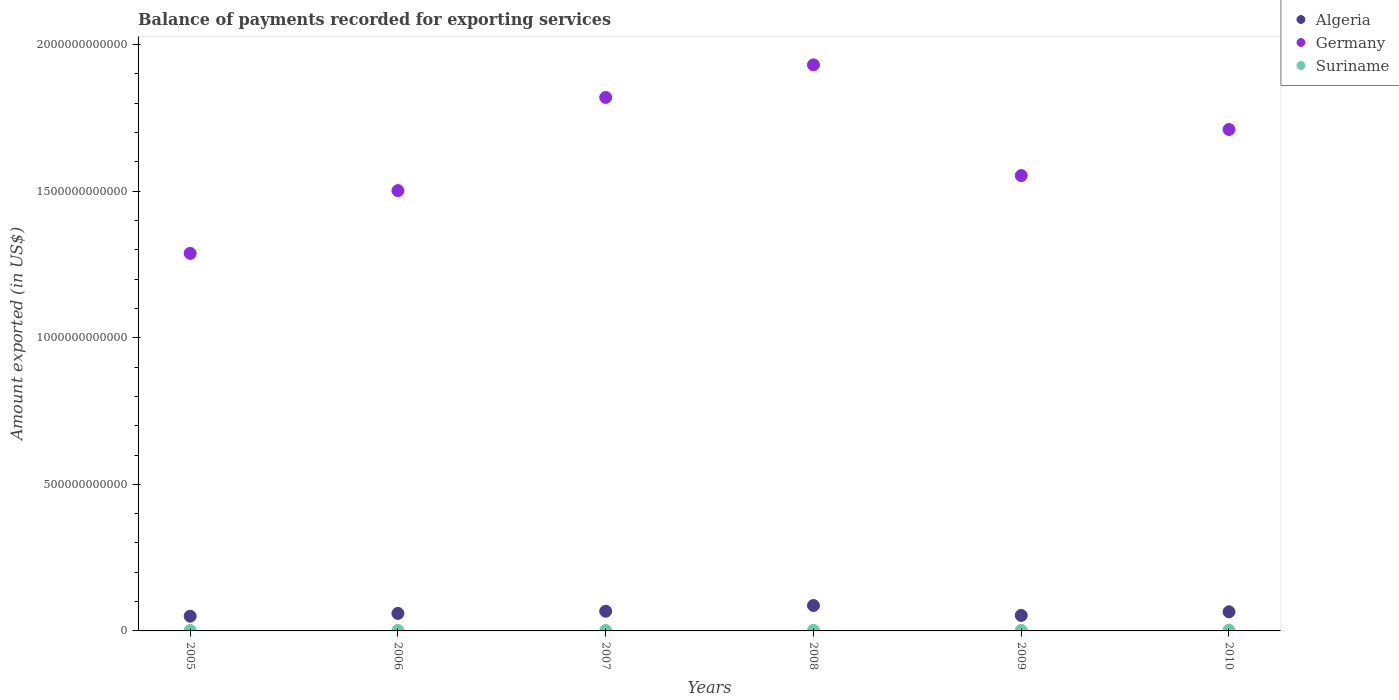How many different coloured dotlines are there?
Your answer should be compact. 3. Is the number of dotlines equal to the number of legend labels?
Provide a succinct answer. Yes. What is the amount exported in Germany in 2006?
Your response must be concise. 1.50e+12. Across all years, what is the maximum amount exported in Suriname?
Provide a short and direct response. 2.35e+09. Across all years, what is the minimum amount exported in Algeria?
Offer a very short reply. 5.03e+1. In which year was the amount exported in Algeria minimum?
Provide a succinct answer. 2005. What is the total amount exported in Germany in the graph?
Provide a short and direct response. 9.80e+12. What is the difference between the amount exported in Germany in 2005 and that in 2010?
Your answer should be very brief. -4.22e+11. What is the difference between the amount exported in Germany in 2006 and the amount exported in Algeria in 2007?
Your response must be concise. 1.43e+12. What is the average amount exported in Germany per year?
Give a very brief answer. 1.63e+12. In the year 2007, what is the difference between the amount exported in Germany and amount exported in Algeria?
Offer a terse response. 1.75e+12. What is the ratio of the amount exported in Algeria in 2006 to that in 2008?
Ensure brevity in your answer.  0.69. Is the amount exported in Germany in 2005 less than that in 2006?
Your response must be concise. Yes. Is the difference between the amount exported in Germany in 2006 and 2010 greater than the difference between the amount exported in Algeria in 2006 and 2010?
Offer a very short reply. No. What is the difference between the highest and the second highest amount exported in Algeria?
Your response must be concise. 1.95e+1. What is the difference between the highest and the lowest amount exported in Germany?
Your answer should be compact. 6.43e+11. Does the amount exported in Algeria monotonically increase over the years?
Make the answer very short. No. How many dotlines are there?
Give a very brief answer. 3. How many years are there in the graph?
Ensure brevity in your answer.  6. What is the difference between two consecutive major ticks on the Y-axis?
Ensure brevity in your answer.  5.00e+11. Are the values on the major ticks of Y-axis written in scientific E-notation?
Give a very brief answer. No. Does the graph contain any zero values?
Your response must be concise. No. Does the graph contain grids?
Give a very brief answer. No. Where does the legend appear in the graph?
Offer a very short reply. Top right. How are the legend labels stacked?
Your answer should be compact. Vertical. What is the title of the graph?
Offer a terse response. Balance of payments recorded for exporting services. What is the label or title of the X-axis?
Provide a short and direct response. Years. What is the label or title of the Y-axis?
Your response must be concise. Amount exported (in US$). What is the Amount exported (in US$) in Algeria in 2005?
Offer a terse response. 5.03e+1. What is the Amount exported (in US$) in Germany in 2005?
Your response must be concise. 1.29e+12. What is the Amount exported (in US$) in Suriname in 2005?
Offer a very short reply. 1.44e+09. What is the Amount exported (in US$) of Algeria in 2006?
Your answer should be compact. 5.97e+1. What is the Amount exported (in US$) in Germany in 2006?
Ensure brevity in your answer.  1.50e+12. What is the Amount exported (in US$) of Suriname in 2006?
Provide a short and direct response. 1.44e+09. What is the Amount exported (in US$) of Algeria in 2007?
Offer a very short reply. 6.71e+1. What is the Amount exported (in US$) of Germany in 2007?
Offer a very short reply. 1.82e+12. What is the Amount exported (in US$) of Suriname in 2007?
Your answer should be compact. 1.66e+09. What is the Amount exported (in US$) in Algeria in 2008?
Your answer should be compact. 8.67e+1. What is the Amount exported (in US$) in Germany in 2008?
Provide a succinct answer. 1.93e+12. What is the Amount exported (in US$) of Suriname in 2008?
Provide a succinct answer. 2.07e+09. What is the Amount exported (in US$) of Algeria in 2009?
Make the answer very short. 5.29e+1. What is the Amount exported (in US$) of Germany in 2009?
Your answer should be compact. 1.55e+12. What is the Amount exported (in US$) of Suriname in 2009?
Offer a terse response. 1.72e+09. What is the Amount exported (in US$) of Algeria in 2010?
Make the answer very short. 6.53e+1. What is the Amount exported (in US$) of Germany in 2010?
Provide a succinct answer. 1.71e+12. What is the Amount exported (in US$) of Suriname in 2010?
Your response must be concise. 2.35e+09. Across all years, what is the maximum Amount exported (in US$) in Algeria?
Your answer should be very brief. 8.67e+1. Across all years, what is the maximum Amount exported (in US$) of Germany?
Give a very brief answer. 1.93e+12. Across all years, what is the maximum Amount exported (in US$) in Suriname?
Offer a terse response. 2.35e+09. Across all years, what is the minimum Amount exported (in US$) of Algeria?
Keep it short and to the point. 5.03e+1. Across all years, what is the minimum Amount exported (in US$) of Germany?
Ensure brevity in your answer.  1.29e+12. Across all years, what is the minimum Amount exported (in US$) in Suriname?
Offer a very short reply. 1.44e+09. What is the total Amount exported (in US$) of Algeria in the graph?
Provide a short and direct response. 3.82e+11. What is the total Amount exported (in US$) in Germany in the graph?
Your answer should be compact. 9.80e+12. What is the total Amount exported (in US$) of Suriname in the graph?
Ensure brevity in your answer.  1.07e+1. What is the difference between the Amount exported (in US$) in Algeria in 2005 and that in 2006?
Make the answer very short. -9.45e+09. What is the difference between the Amount exported (in US$) of Germany in 2005 and that in 2006?
Provide a short and direct response. -2.14e+11. What is the difference between the Amount exported (in US$) in Suriname in 2005 and that in 2006?
Keep it short and to the point. 3.50e+06. What is the difference between the Amount exported (in US$) of Algeria in 2005 and that in 2007?
Offer a terse response. -1.69e+1. What is the difference between the Amount exported (in US$) of Germany in 2005 and that in 2007?
Provide a succinct answer. -5.32e+11. What is the difference between the Amount exported (in US$) of Suriname in 2005 and that in 2007?
Offer a very short reply. -2.16e+08. What is the difference between the Amount exported (in US$) of Algeria in 2005 and that in 2008?
Your answer should be very brief. -3.64e+1. What is the difference between the Amount exported (in US$) in Germany in 2005 and that in 2008?
Give a very brief answer. -6.43e+11. What is the difference between the Amount exported (in US$) in Suriname in 2005 and that in 2008?
Your answer should be compact. -6.30e+08. What is the difference between the Amount exported (in US$) of Algeria in 2005 and that in 2009?
Keep it short and to the point. -2.62e+09. What is the difference between the Amount exported (in US$) in Germany in 2005 and that in 2009?
Your answer should be compact. -2.65e+11. What is the difference between the Amount exported (in US$) of Suriname in 2005 and that in 2009?
Ensure brevity in your answer.  -2.79e+08. What is the difference between the Amount exported (in US$) in Algeria in 2005 and that in 2010?
Offer a very short reply. -1.50e+1. What is the difference between the Amount exported (in US$) in Germany in 2005 and that in 2010?
Your answer should be very brief. -4.22e+11. What is the difference between the Amount exported (in US$) of Suriname in 2005 and that in 2010?
Provide a succinct answer. -9.12e+08. What is the difference between the Amount exported (in US$) of Algeria in 2006 and that in 2007?
Offer a terse response. -7.41e+09. What is the difference between the Amount exported (in US$) of Germany in 2006 and that in 2007?
Provide a short and direct response. -3.18e+11. What is the difference between the Amount exported (in US$) of Suriname in 2006 and that in 2007?
Provide a succinct answer. -2.20e+08. What is the difference between the Amount exported (in US$) of Algeria in 2006 and that in 2008?
Provide a short and direct response. -2.69e+1. What is the difference between the Amount exported (in US$) of Germany in 2006 and that in 2008?
Your answer should be compact. -4.29e+11. What is the difference between the Amount exported (in US$) of Suriname in 2006 and that in 2008?
Offer a very short reply. -6.34e+08. What is the difference between the Amount exported (in US$) of Algeria in 2006 and that in 2009?
Offer a very short reply. 6.83e+09. What is the difference between the Amount exported (in US$) in Germany in 2006 and that in 2009?
Your response must be concise. -5.12e+1. What is the difference between the Amount exported (in US$) of Suriname in 2006 and that in 2009?
Provide a short and direct response. -2.82e+08. What is the difference between the Amount exported (in US$) in Algeria in 2006 and that in 2010?
Offer a very short reply. -5.54e+09. What is the difference between the Amount exported (in US$) of Germany in 2006 and that in 2010?
Offer a very short reply. -2.08e+11. What is the difference between the Amount exported (in US$) of Suriname in 2006 and that in 2010?
Ensure brevity in your answer.  -9.16e+08. What is the difference between the Amount exported (in US$) in Algeria in 2007 and that in 2008?
Offer a terse response. -1.95e+1. What is the difference between the Amount exported (in US$) of Germany in 2007 and that in 2008?
Your answer should be compact. -1.11e+11. What is the difference between the Amount exported (in US$) of Suriname in 2007 and that in 2008?
Ensure brevity in your answer.  -4.14e+08. What is the difference between the Amount exported (in US$) in Algeria in 2007 and that in 2009?
Ensure brevity in your answer.  1.42e+1. What is the difference between the Amount exported (in US$) in Germany in 2007 and that in 2009?
Offer a terse response. 2.66e+11. What is the difference between the Amount exported (in US$) in Suriname in 2007 and that in 2009?
Make the answer very short. -6.23e+07. What is the difference between the Amount exported (in US$) of Algeria in 2007 and that in 2010?
Provide a succinct answer. 1.87e+09. What is the difference between the Amount exported (in US$) of Germany in 2007 and that in 2010?
Your response must be concise. 1.09e+11. What is the difference between the Amount exported (in US$) of Suriname in 2007 and that in 2010?
Make the answer very short. -6.96e+08. What is the difference between the Amount exported (in US$) in Algeria in 2008 and that in 2009?
Your answer should be very brief. 3.38e+1. What is the difference between the Amount exported (in US$) in Germany in 2008 and that in 2009?
Offer a very short reply. 3.78e+11. What is the difference between the Amount exported (in US$) in Suriname in 2008 and that in 2009?
Provide a succinct answer. 3.52e+08. What is the difference between the Amount exported (in US$) of Algeria in 2008 and that in 2010?
Your response must be concise. 2.14e+1. What is the difference between the Amount exported (in US$) in Germany in 2008 and that in 2010?
Your answer should be compact. 2.20e+11. What is the difference between the Amount exported (in US$) of Suriname in 2008 and that in 2010?
Offer a terse response. -2.82e+08. What is the difference between the Amount exported (in US$) of Algeria in 2009 and that in 2010?
Ensure brevity in your answer.  -1.24e+1. What is the difference between the Amount exported (in US$) in Germany in 2009 and that in 2010?
Make the answer very short. -1.57e+11. What is the difference between the Amount exported (in US$) of Suriname in 2009 and that in 2010?
Offer a terse response. -6.33e+08. What is the difference between the Amount exported (in US$) of Algeria in 2005 and the Amount exported (in US$) of Germany in 2006?
Your answer should be compact. -1.45e+12. What is the difference between the Amount exported (in US$) of Algeria in 2005 and the Amount exported (in US$) of Suriname in 2006?
Your response must be concise. 4.88e+1. What is the difference between the Amount exported (in US$) in Germany in 2005 and the Amount exported (in US$) in Suriname in 2006?
Your response must be concise. 1.29e+12. What is the difference between the Amount exported (in US$) in Algeria in 2005 and the Amount exported (in US$) in Germany in 2007?
Offer a very short reply. -1.77e+12. What is the difference between the Amount exported (in US$) of Algeria in 2005 and the Amount exported (in US$) of Suriname in 2007?
Keep it short and to the point. 4.86e+1. What is the difference between the Amount exported (in US$) in Germany in 2005 and the Amount exported (in US$) in Suriname in 2007?
Offer a very short reply. 1.29e+12. What is the difference between the Amount exported (in US$) of Algeria in 2005 and the Amount exported (in US$) of Germany in 2008?
Your answer should be very brief. -1.88e+12. What is the difference between the Amount exported (in US$) of Algeria in 2005 and the Amount exported (in US$) of Suriname in 2008?
Ensure brevity in your answer.  4.82e+1. What is the difference between the Amount exported (in US$) in Germany in 2005 and the Amount exported (in US$) in Suriname in 2008?
Ensure brevity in your answer.  1.29e+12. What is the difference between the Amount exported (in US$) of Algeria in 2005 and the Amount exported (in US$) of Germany in 2009?
Your response must be concise. -1.50e+12. What is the difference between the Amount exported (in US$) in Algeria in 2005 and the Amount exported (in US$) in Suriname in 2009?
Provide a short and direct response. 4.85e+1. What is the difference between the Amount exported (in US$) of Germany in 2005 and the Amount exported (in US$) of Suriname in 2009?
Provide a succinct answer. 1.29e+12. What is the difference between the Amount exported (in US$) of Algeria in 2005 and the Amount exported (in US$) of Germany in 2010?
Your answer should be very brief. -1.66e+12. What is the difference between the Amount exported (in US$) of Algeria in 2005 and the Amount exported (in US$) of Suriname in 2010?
Offer a terse response. 4.79e+1. What is the difference between the Amount exported (in US$) in Germany in 2005 and the Amount exported (in US$) in Suriname in 2010?
Your response must be concise. 1.29e+12. What is the difference between the Amount exported (in US$) in Algeria in 2006 and the Amount exported (in US$) in Germany in 2007?
Ensure brevity in your answer.  -1.76e+12. What is the difference between the Amount exported (in US$) in Algeria in 2006 and the Amount exported (in US$) in Suriname in 2007?
Ensure brevity in your answer.  5.81e+1. What is the difference between the Amount exported (in US$) in Germany in 2006 and the Amount exported (in US$) in Suriname in 2007?
Ensure brevity in your answer.  1.50e+12. What is the difference between the Amount exported (in US$) in Algeria in 2006 and the Amount exported (in US$) in Germany in 2008?
Offer a terse response. -1.87e+12. What is the difference between the Amount exported (in US$) of Algeria in 2006 and the Amount exported (in US$) of Suriname in 2008?
Give a very brief answer. 5.77e+1. What is the difference between the Amount exported (in US$) of Germany in 2006 and the Amount exported (in US$) of Suriname in 2008?
Provide a succinct answer. 1.50e+12. What is the difference between the Amount exported (in US$) of Algeria in 2006 and the Amount exported (in US$) of Germany in 2009?
Your answer should be very brief. -1.49e+12. What is the difference between the Amount exported (in US$) of Algeria in 2006 and the Amount exported (in US$) of Suriname in 2009?
Provide a short and direct response. 5.80e+1. What is the difference between the Amount exported (in US$) of Germany in 2006 and the Amount exported (in US$) of Suriname in 2009?
Provide a short and direct response. 1.50e+12. What is the difference between the Amount exported (in US$) of Algeria in 2006 and the Amount exported (in US$) of Germany in 2010?
Your answer should be very brief. -1.65e+12. What is the difference between the Amount exported (in US$) in Algeria in 2006 and the Amount exported (in US$) in Suriname in 2010?
Make the answer very short. 5.74e+1. What is the difference between the Amount exported (in US$) of Germany in 2006 and the Amount exported (in US$) of Suriname in 2010?
Your answer should be very brief. 1.50e+12. What is the difference between the Amount exported (in US$) in Algeria in 2007 and the Amount exported (in US$) in Germany in 2008?
Your answer should be very brief. -1.86e+12. What is the difference between the Amount exported (in US$) of Algeria in 2007 and the Amount exported (in US$) of Suriname in 2008?
Provide a succinct answer. 6.51e+1. What is the difference between the Amount exported (in US$) in Germany in 2007 and the Amount exported (in US$) in Suriname in 2008?
Your response must be concise. 1.82e+12. What is the difference between the Amount exported (in US$) of Algeria in 2007 and the Amount exported (in US$) of Germany in 2009?
Your answer should be very brief. -1.49e+12. What is the difference between the Amount exported (in US$) of Algeria in 2007 and the Amount exported (in US$) of Suriname in 2009?
Give a very brief answer. 6.54e+1. What is the difference between the Amount exported (in US$) of Germany in 2007 and the Amount exported (in US$) of Suriname in 2009?
Keep it short and to the point. 1.82e+12. What is the difference between the Amount exported (in US$) of Algeria in 2007 and the Amount exported (in US$) of Germany in 2010?
Offer a very short reply. -1.64e+12. What is the difference between the Amount exported (in US$) of Algeria in 2007 and the Amount exported (in US$) of Suriname in 2010?
Offer a terse response. 6.48e+1. What is the difference between the Amount exported (in US$) of Germany in 2007 and the Amount exported (in US$) of Suriname in 2010?
Provide a short and direct response. 1.82e+12. What is the difference between the Amount exported (in US$) in Algeria in 2008 and the Amount exported (in US$) in Germany in 2009?
Your answer should be compact. -1.47e+12. What is the difference between the Amount exported (in US$) in Algeria in 2008 and the Amount exported (in US$) in Suriname in 2009?
Keep it short and to the point. 8.49e+1. What is the difference between the Amount exported (in US$) in Germany in 2008 and the Amount exported (in US$) in Suriname in 2009?
Give a very brief answer. 1.93e+12. What is the difference between the Amount exported (in US$) of Algeria in 2008 and the Amount exported (in US$) of Germany in 2010?
Give a very brief answer. -1.62e+12. What is the difference between the Amount exported (in US$) of Algeria in 2008 and the Amount exported (in US$) of Suriname in 2010?
Offer a terse response. 8.43e+1. What is the difference between the Amount exported (in US$) in Germany in 2008 and the Amount exported (in US$) in Suriname in 2010?
Your response must be concise. 1.93e+12. What is the difference between the Amount exported (in US$) in Algeria in 2009 and the Amount exported (in US$) in Germany in 2010?
Ensure brevity in your answer.  -1.66e+12. What is the difference between the Amount exported (in US$) of Algeria in 2009 and the Amount exported (in US$) of Suriname in 2010?
Make the answer very short. 5.05e+1. What is the difference between the Amount exported (in US$) in Germany in 2009 and the Amount exported (in US$) in Suriname in 2010?
Give a very brief answer. 1.55e+12. What is the average Amount exported (in US$) in Algeria per year?
Offer a terse response. 6.37e+1. What is the average Amount exported (in US$) of Germany per year?
Provide a short and direct response. 1.63e+12. What is the average Amount exported (in US$) in Suriname per year?
Offer a terse response. 1.78e+09. In the year 2005, what is the difference between the Amount exported (in US$) of Algeria and Amount exported (in US$) of Germany?
Provide a succinct answer. -1.24e+12. In the year 2005, what is the difference between the Amount exported (in US$) of Algeria and Amount exported (in US$) of Suriname?
Your answer should be compact. 4.88e+1. In the year 2005, what is the difference between the Amount exported (in US$) in Germany and Amount exported (in US$) in Suriname?
Ensure brevity in your answer.  1.29e+12. In the year 2006, what is the difference between the Amount exported (in US$) in Algeria and Amount exported (in US$) in Germany?
Provide a succinct answer. -1.44e+12. In the year 2006, what is the difference between the Amount exported (in US$) of Algeria and Amount exported (in US$) of Suriname?
Provide a succinct answer. 5.83e+1. In the year 2006, what is the difference between the Amount exported (in US$) in Germany and Amount exported (in US$) in Suriname?
Provide a succinct answer. 1.50e+12. In the year 2007, what is the difference between the Amount exported (in US$) of Algeria and Amount exported (in US$) of Germany?
Offer a terse response. -1.75e+12. In the year 2007, what is the difference between the Amount exported (in US$) of Algeria and Amount exported (in US$) of Suriname?
Your response must be concise. 6.55e+1. In the year 2007, what is the difference between the Amount exported (in US$) in Germany and Amount exported (in US$) in Suriname?
Ensure brevity in your answer.  1.82e+12. In the year 2008, what is the difference between the Amount exported (in US$) in Algeria and Amount exported (in US$) in Germany?
Your response must be concise. -1.84e+12. In the year 2008, what is the difference between the Amount exported (in US$) of Algeria and Amount exported (in US$) of Suriname?
Provide a succinct answer. 8.46e+1. In the year 2008, what is the difference between the Amount exported (in US$) in Germany and Amount exported (in US$) in Suriname?
Keep it short and to the point. 1.93e+12. In the year 2009, what is the difference between the Amount exported (in US$) in Algeria and Amount exported (in US$) in Germany?
Give a very brief answer. -1.50e+12. In the year 2009, what is the difference between the Amount exported (in US$) of Algeria and Amount exported (in US$) of Suriname?
Your response must be concise. 5.12e+1. In the year 2009, what is the difference between the Amount exported (in US$) in Germany and Amount exported (in US$) in Suriname?
Keep it short and to the point. 1.55e+12. In the year 2010, what is the difference between the Amount exported (in US$) in Algeria and Amount exported (in US$) in Germany?
Offer a terse response. -1.65e+12. In the year 2010, what is the difference between the Amount exported (in US$) of Algeria and Amount exported (in US$) of Suriname?
Provide a short and direct response. 6.29e+1. In the year 2010, what is the difference between the Amount exported (in US$) in Germany and Amount exported (in US$) in Suriname?
Ensure brevity in your answer.  1.71e+12. What is the ratio of the Amount exported (in US$) in Algeria in 2005 to that in 2006?
Keep it short and to the point. 0.84. What is the ratio of the Amount exported (in US$) of Germany in 2005 to that in 2006?
Keep it short and to the point. 0.86. What is the ratio of the Amount exported (in US$) in Suriname in 2005 to that in 2006?
Provide a succinct answer. 1. What is the ratio of the Amount exported (in US$) in Algeria in 2005 to that in 2007?
Offer a very short reply. 0.75. What is the ratio of the Amount exported (in US$) in Germany in 2005 to that in 2007?
Your answer should be very brief. 0.71. What is the ratio of the Amount exported (in US$) in Suriname in 2005 to that in 2007?
Provide a succinct answer. 0.87. What is the ratio of the Amount exported (in US$) of Algeria in 2005 to that in 2008?
Ensure brevity in your answer.  0.58. What is the ratio of the Amount exported (in US$) in Germany in 2005 to that in 2008?
Your answer should be compact. 0.67. What is the ratio of the Amount exported (in US$) of Suriname in 2005 to that in 2008?
Your answer should be very brief. 0.7. What is the ratio of the Amount exported (in US$) in Algeria in 2005 to that in 2009?
Your response must be concise. 0.95. What is the ratio of the Amount exported (in US$) in Germany in 2005 to that in 2009?
Give a very brief answer. 0.83. What is the ratio of the Amount exported (in US$) in Suriname in 2005 to that in 2009?
Keep it short and to the point. 0.84. What is the ratio of the Amount exported (in US$) in Algeria in 2005 to that in 2010?
Ensure brevity in your answer.  0.77. What is the ratio of the Amount exported (in US$) in Germany in 2005 to that in 2010?
Your answer should be compact. 0.75. What is the ratio of the Amount exported (in US$) of Suriname in 2005 to that in 2010?
Ensure brevity in your answer.  0.61. What is the ratio of the Amount exported (in US$) of Algeria in 2006 to that in 2007?
Offer a terse response. 0.89. What is the ratio of the Amount exported (in US$) in Germany in 2006 to that in 2007?
Give a very brief answer. 0.83. What is the ratio of the Amount exported (in US$) in Suriname in 2006 to that in 2007?
Provide a succinct answer. 0.87. What is the ratio of the Amount exported (in US$) in Algeria in 2006 to that in 2008?
Your answer should be compact. 0.69. What is the ratio of the Amount exported (in US$) of Germany in 2006 to that in 2008?
Offer a terse response. 0.78. What is the ratio of the Amount exported (in US$) in Suriname in 2006 to that in 2008?
Your answer should be very brief. 0.69. What is the ratio of the Amount exported (in US$) in Algeria in 2006 to that in 2009?
Your answer should be compact. 1.13. What is the ratio of the Amount exported (in US$) of Germany in 2006 to that in 2009?
Give a very brief answer. 0.97. What is the ratio of the Amount exported (in US$) in Suriname in 2006 to that in 2009?
Ensure brevity in your answer.  0.84. What is the ratio of the Amount exported (in US$) of Algeria in 2006 to that in 2010?
Keep it short and to the point. 0.92. What is the ratio of the Amount exported (in US$) of Germany in 2006 to that in 2010?
Make the answer very short. 0.88. What is the ratio of the Amount exported (in US$) in Suriname in 2006 to that in 2010?
Your answer should be compact. 0.61. What is the ratio of the Amount exported (in US$) of Algeria in 2007 to that in 2008?
Ensure brevity in your answer.  0.77. What is the ratio of the Amount exported (in US$) in Germany in 2007 to that in 2008?
Make the answer very short. 0.94. What is the ratio of the Amount exported (in US$) of Algeria in 2007 to that in 2009?
Your answer should be compact. 1.27. What is the ratio of the Amount exported (in US$) of Germany in 2007 to that in 2009?
Offer a very short reply. 1.17. What is the ratio of the Amount exported (in US$) of Suriname in 2007 to that in 2009?
Provide a succinct answer. 0.96. What is the ratio of the Amount exported (in US$) in Algeria in 2007 to that in 2010?
Your answer should be very brief. 1.03. What is the ratio of the Amount exported (in US$) of Germany in 2007 to that in 2010?
Give a very brief answer. 1.06. What is the ratio of the Amount exported (in US$) in Suriname in 2007 to that in 2010?
Offer a terse response. 0.7. What is the ratio of the Amount exported (in US$) of Algeria in 2008 to that in 2009?
Your answer should be very brief. 1.64. What is the ratio of the Amount exported (in US$) in Germany in 2008 to that in 2009?
Offer a terse response. 1.24. What is the ratio of the Amount exported (in US$) in Suriname in 2008 to that in 2009?
Give a very brief answer. 1.2. What is the ratio of the Amount exported (in US$) in Algeria in 2008 to that in 2010?
Your answer should be very brief. 1.33. What is the ratio of the Amount exported (in US$) of Germany in 2008 to that in 2010?
Provide a short and direct response. 1.13. What is the ratio of the Amount exported (in US$) in Suriname in 2008 to that in 2010?
Ensure brevity in your answer.  0.88. What is the ratio of the Amount exported (in US$) of Algeria in 2009 to that in 2010?
Provide a succinct answer. 0.81. What is the ratio of the Amount exported (in US$) of Germany in 2009 to that in 2010?
Provide a short and direct response. 0.91. What is the ratio of the Amount exported (in US$) of Suriname in 2009 to that in 2010?
Keep it short and to the point. 0.73. What is the difference between the highest and the second highest Amount exported (in US$) of Algeria?
Provide a short and direct response. 1.95e+1. What is the difference between the highest and the second highest Amount exported (in US$) of Germany?
Make the answer very short. 1.11e+11. What is the difference between the highest and the second highest Amount exported (in US$) in Suriname?
Make the answer very short. 2.82e+08. What is the difference between the highest and the lowest Amount exported (in US$) in Algeria?
Keep it short and to the point. 3.64e+1. What is the difference between the highest and the lowest Amount exported (in US$) of Germany?
Your response must be concise. 6.43e+11. What is the difference between the highest and the lowest Amount exported (in US$) in Suriname?
Provide a succinct answer. 9.16e+08. 